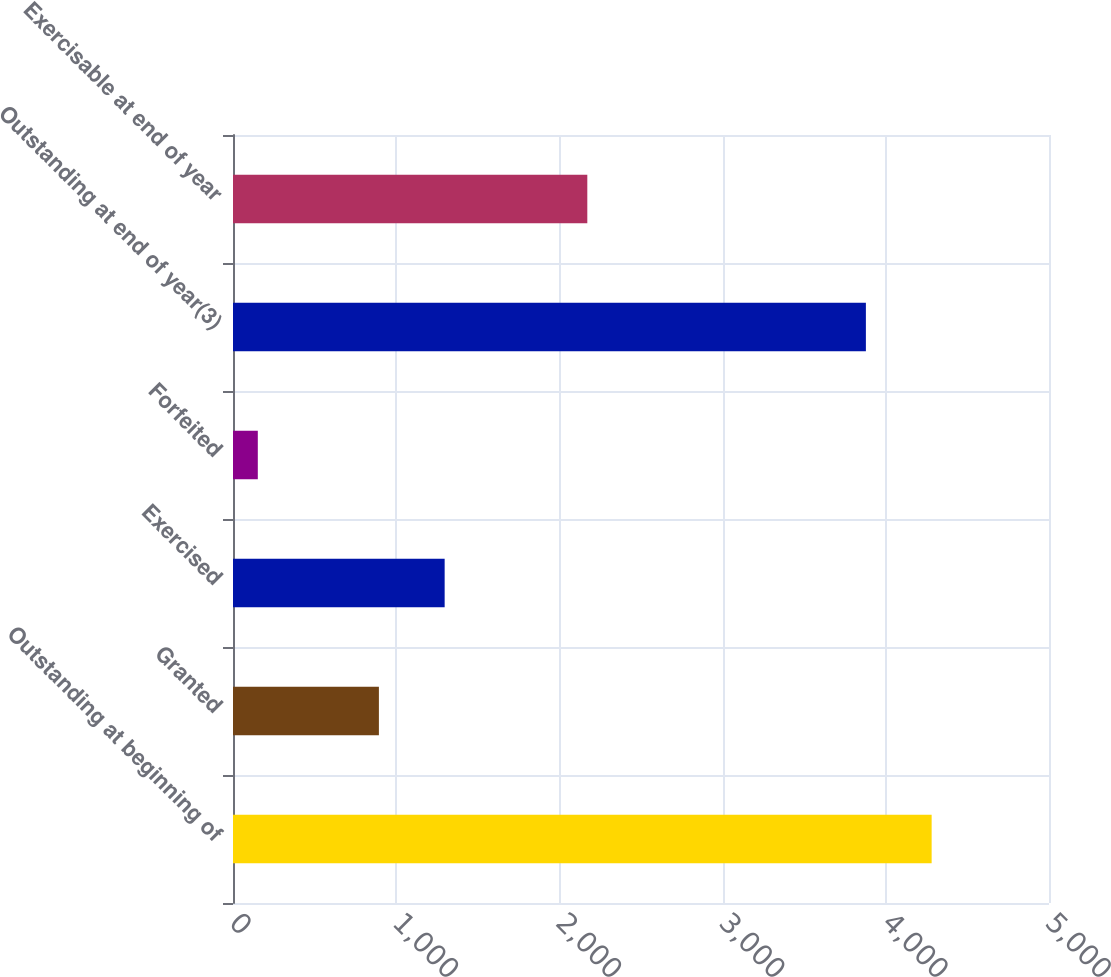Convert chart. <chart><loc_0><loc_0><loc_500><loc_500><bar_chart><fcel>Outstanding at beginning of<fcel>Granted<fcel>Exercised<fcel>Forfeited<fcel>Outstanding at end of year(3)<fcel>Exercisable at end of year<nl><fcel>4280.9<fcel>894<fcel>1296.9<fcel>152<fcel>3878<fcel>2171<nl></chart> 